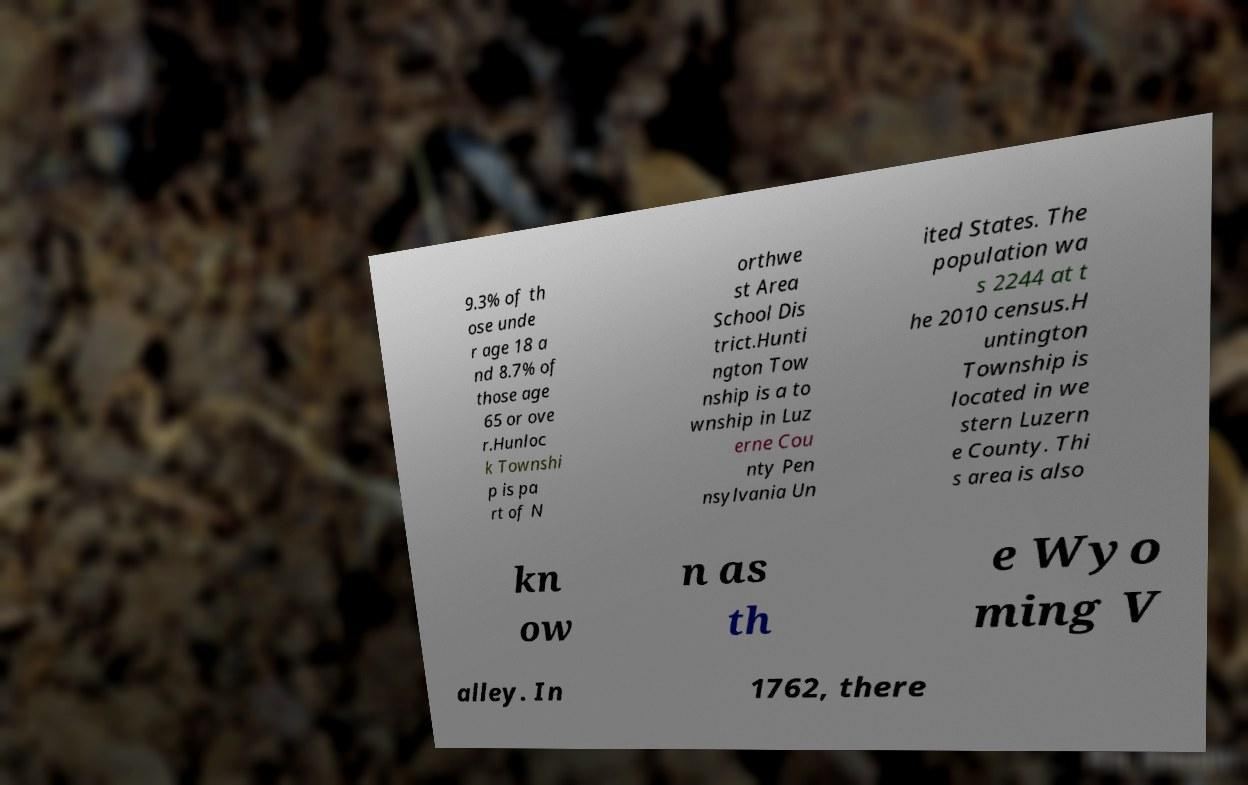For documentation purposes, I need the text within this image transcribed. Could you provide that? 9.3% of th ose unde r age 18 a nd 8.7% of those age 65 or ove r.Hunloc k Townshi p is pa rt of N orthwe st Area School Dis trict.Hunti ngton Tow nship is a to wnship in Luz erne Cou nty Pen nsylvania Un ited States. The population wa s 2244 at t he 2010 census.H untington Township is located in we stern Luzern e County. Thi s area is also kn ow n as th e Wyo ming V alley. In 1762, there 